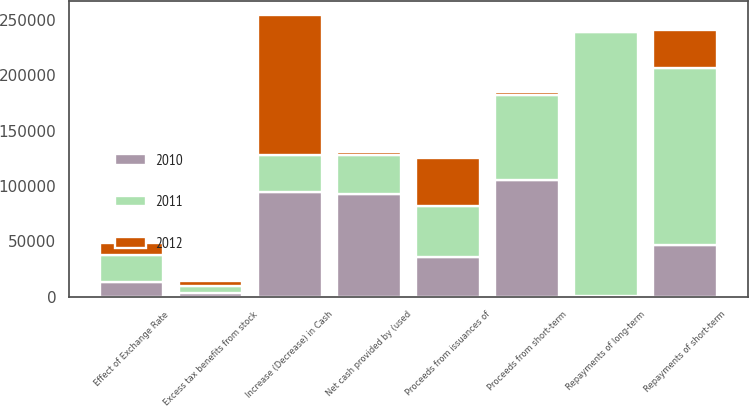<chart> <loc_0><loc_0><loc_500><loc_500><stacked_bar_chart><ecel><fcel>Repayments of long-term<fcel>Proceeds from short-term<fcel>Repayments of short-term<fcel>Proceeds from issuances of<fcel>Excess tax benefits from stock<fcel>Net cash provided by (used<fcel>Effect of Exchange Rate<fcel>Increase (Decrease) in Cash<nl><fcel>2012<fcel>98<fcel>2586<fcel>34709<fcel>43568<fcel>3956<fcel>2724<fcel>10870<fcel>126824<nl><fcel>2011<fcel>239189<fcel>77055<fcel>159394<fcel>45943<fcel>6837<fcel>34709<fcel>24796<fcel>33209<nl><fcel>2010<fcel>217<fcel>105184<fcel>47094<fcel>36209<fcel>2884<fcel>93114<fcel>13026<fcel>94777<nl></chart> 